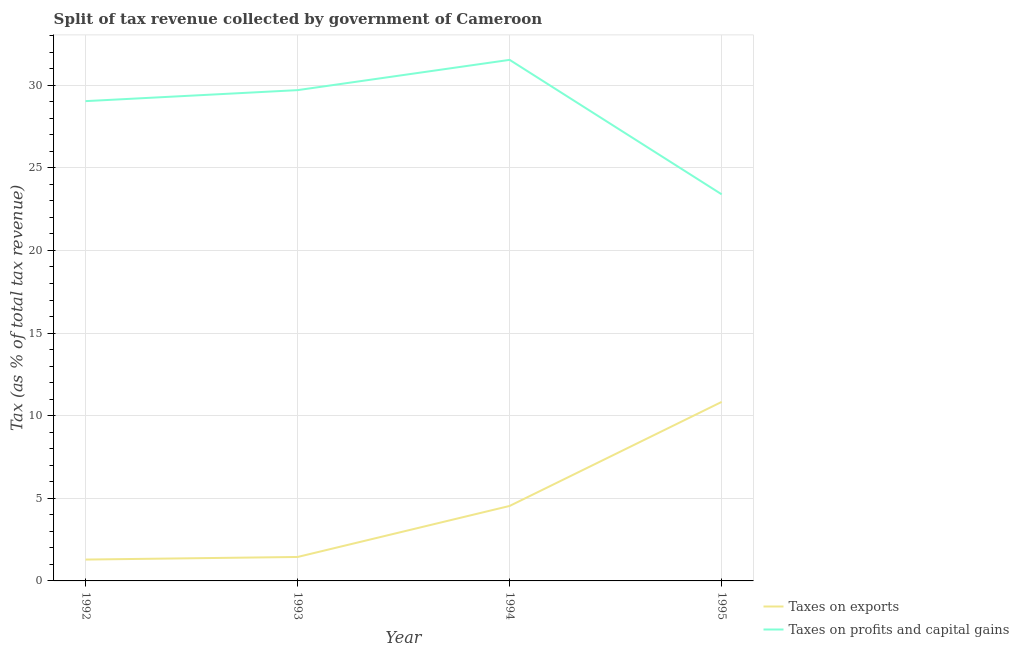Does the line corresponding to percentage of revenue obtained from taxes on exports intersect with the line corresponding to percentage of revenue obtained from taxes on profits and capital gains?
Keep it short and to the point. No. Is the number of lines equal to the number of legend labels?
Your answer should be compact. Yes. What is the percentage of revenue obtained from taxes on exports in 1994?
Your response must be concise. 4.54. Across all years, what is the maximum percentage of revenue obtained from taxes on exports?
Keep it short and to the point. 10.83. Across all years, what is the minimum percentage of revenue obtained from taxes on profits and capital gains?
Provide a succinct answer. 23.4. In which year was the percentage of revenue obtained from taxes on exports maximum?
Give a very brief answer. 1995. What is the total percentage of revenue obtained from taxes on profits and capital gains in the graph?
Your answer should be compact. 113.67. What is the difference between the percentage of revenue obtained from taxes on exports in 1992 and that in 1995?
Your answer should be very brief. -9.54. What is the difference between the percentage of revenue obtained from taxes on exports in 1992 and the percentage of revenue obtained from taxes on profits and capital gains in 1995?
Keep it short and to the point. -22.1. What is the average percentage of revenue obtained from taxes on exports per year?
Provide a succinct answer. 4.53. In the year 1993, what is the difference between the percentage of revenue obtained from taxes on exports and percentage of revenue obtained from taxes on profits and capital gains?
Offer a very short reply. -28.25. In how many years, is the percentage of revenue obtained from taxes on exports greater than 17 %?
Provide a short and direct response. 0. What is the ratio of the percentage of revenue obtained from taxes on profits and capital gains in 1993 to that in 1995?
Your answer should be compact. 1.27. What is the difference between the highest and the second highest percentage of revenue obtained from taxes on profits and capital gains?
Make the answer very short. 1.83. What is the difference between the highest and the lowest percentage of revenue obtained from taxes on exports?
Your answer should be compact. 9.54. Is the sum of the percentage of revenue obtained from taxes on profits and capital gains in 1994 and 1995 greater than the maximum percentage of revenue obtained from taxes on exports across all years?
Your answer should be compact. Yes. Is the percentage of revenue obtained from taxes on exports strictly less than the percentage of revenue obtained from taxes on profits and capital gains over the years?
Your answer should be compact. Yes. How many lines are there?
Make the answer very short. 2. How many years are there in the graph?
Ensure brevity in your answer.  4. Are the values on the major ticks of Y-axis written in scientific E-notation?
Keep it short and to the point. No. Does the graph contain any zero values?
Your response must be concise. No. Where does the legend appear in the graph?
Ensure brevity in your answer.  Bottom right. How many legend labels are there?
Provide a short and direct response. 2. What is the title of the graph?
Offer a very short reply. Split of tax revenue collected by government of Cameroon. What is the label or title of the X-axis?
Give a very brief answer. Year. What is the label or title of the Y-axis?
Keep it short and to the point. Tax (as % of total tax revenue). What is the Tax (as % of total tax revenue) in Taxes on exports in 1992?
Offer a very short reply. 1.29. What is the Tax (as % of total tax revenue) of Taxes on profits and capital gains in 1992?
Ensure brevity in your answer.  29.04. What is the Tax (as % of total tax revenue) in Taxes on exports in 1993?
Keep it short and to the point. 1.45. What is the Tax (as % of total tax revenue) in Taxes on profits and capital gains in 1993?
Ensure brevity in your answer.  29.7. What is the Tax (as % of total tax revenue) of Taxes on exports in 1994?
Your answer should be very brief. 4.54. What is the Tax (as % of total tax revenue) in Taxes on profits and capital gains in 1994?
Make the answer very short. 31.54. What is the Tax (as % of total tax revenue) of Taxes on exports in 1995?
Offer a terse response. 10.83. What is the Tax (as % of total tax revenue) of Taxes on profits and capital gains in 1995?
Provide a short and direct response. 23.4. Across all years, what is the maximum Tax (as % of total tax revenue) in Taxes on exports?
Provide a succinct answer. 10.83. Across all years, what is the maximum Tax (as % of total tax revenue) in Taxes on profits and capital gains?
Provide a short and direct response. 31.54. Across all years, what is the minimum Tax (as % of total tax revenue) of Taxes on exports?
Your answer should be very brief. 1.29. Across all years, what is the minimum Tax (as % of total tax revenue) in Taxes on profits and capital gains?
Your response must be concise. 23.4. What is the total Tax (as % of total tax revenue) of Taxes on exports in the graph?
Make the answer very short. 18.12. What is the total Tax (as % of total tax revenue) in Taxes on profits and capital gains in the graph?
Offer a very short reply. 113.67. What is the difference between the Tax (as % of total tax revenue) of Taxes on exports in 1992 and that in 1993?
Ensure brevity in your answer.  -0.16. What is the difference between the Tax (as % of total tax revenue) in Taxes on profits and capital gains in 1992 and that in 1993?
Your answer should be compact. -0.67. What is the difference between the Tax (as % of total tax revenue) in Taxes on exports in 1992 and that in 1994?
Ensure brevity in your answer.  -3.24. What is the difference between the Tax (as % of total tax revenue) in Taxes on profits and capital gains in 1992 and that in 1994?
Keep it short and to the point. -2.5. What is the difference between the Tax (as % of total tax revenue) of Taxes on exports in 1992 and that in 1995?
Ensure brevity in your answer.  -9.54. What is the difference between the Tax (as % of total tax revenue) in Taxes on profits and capital gains in 1992 and that in 1995?
Your answer should be compact. 5.64. What is the difference between the Tax (as % of total tax revenue) of Taxes on exports in 1993 and that in 1994?
Your answer should be compact. -3.09. What is the difference between the Tax (as % of total tax revenue) in Taxes on profits and capital gains in 1993 and that in 1994?
Ensure brevity in your answer.  -1.83. What is the difference between the Tax (as % of total tax revenue) of Taxes on exports in 1993 and that in 1995?
Your response must be concise. -9.39. What is the difference between the Tax (as % of total tax revenue) of Taxes on profits and capital gains in 1993 and that in 1995?
Keep it short and to the point. 6.31. What is the difference between the Tax (as % of total tax revenue) of Taxes on exports in 1994 and that in 1995?
Your answer should be very brief. -6.3. What is the difference between the Tax (as % of total tax revenue) in Taxes on profits and capital gains in 1994 and that in 1995?
Your answer should be very brief. 8.14. What is the difference between the Tax (as % of total tax revenue) in Taxes on exports in 1992 and the Tax (as % of total tax revenue) in Taxes on profits and capital gains in 1993?
Your answer should be compact. -28.41. What is the difference between the Tax (as % of total tax revenue) of Taxes on exports in 1992 and the Tax (as % of total tax revenue) of Taxes on profits and capital gains in 1994?
Ensure brevity in your answer.  -30.24. What is the difference between the Tax (as % of total tax revenue) of Taxes on exports in 1992 and the Tax (as % of total tax revenue) of Taxes on profits and capital gains in 1995?
Ensure brevity in your answer.  -22.1. What is the difference between the Tax (as % of total tax revenue) in Taxes on exports in 1993 and the Tax (as % of total tax revenue) in Taxes on profits and capital gains in 1994?
Keep it short and to the point. -30.09. What is the difference between the Tax (as % of total tax revenue) in Taxes on exports in 1993 and the Tax (as % of total tax revenue) in Taxes on profits and capital gains in 1995?
Your answer should be very brief. -21.95. What is the difference between the Tax (as % of total tax revenue) in Taxes on exports in 1994 and the Tax (as % of total tax revenue) in Taxes on profits and capital gains in 1995?
Make the answer very short. -18.86. What is the average Tax (as % of total tax revenue) in Taxes on exports per year?
Make the answer very short. 4.53. What is the average Tax (as % of total tax revenue) of Taxes on profits and capital gains per year?
Offer a terse response. 28.42. In the year 1992, what is the difference between the Tax (as % of total tax revenue) of Taxes on exports and Tax (as % of total tax revenue) of Taxes on profits and capital gains?
Your answer should be compact. -27.75. In the year 1993, what is the difference between the Tax (as % of total tax revenue) of Taxes on exports and Tax (as % of total tax revenue) of Taxes on profits and capital gains?
Make the answer very short. -28.25. In the year 1994, what is the difference between the Tax (as % of total tax revenue) in Taxes on exports and Tax (as % of total tax revenue) in Taxes on profits and capital gains?
Provide a succinct answer. -27. In the year 1995, what is the difference between the Tax (as % of total tax revenue) in Taxes on exports and Tax (as % of total tax revenue) in Taxes on profits and capital gains?
Your answer should be compact. -12.56. What is the ratio of the Tax (as % of total tax revenue) of Taxes on exports in 1992 to that in 1993?
Your answer should be very brief. 0.89. What is the ratio of the Tax (as % of total tax revenue) in Taxes on profits and capital gains in 1992 to that in 1993?
Offer a very short reply. 0.98. What is the ratio of the Tax (as % of total tax revenue) of Taxes on exports in 1992 to that in 1994?
Give a very brief answer. 0.28. What is the ratio of the Tax (as % of total tax revenue) in Taxes on profits and capital gains in 1992 to that in 1994?
Keep it short and to the point. 0.92. What is the ratio of the Tax (as % of total tax revenue) in Taxes on exports in 1992 to that in 1995?
Give a very brief answer. 0.12. What is the ratio of the Tax (as % of total tax revenue) in Taxes on profits and capital gains in 1992 to that in 1995?
Your answer should be very brief. 1.24. What is the ratio of the Tax (as % of total tax revenue) in Taxes on exports in 1993 to that in 1994?
Provide a succinct answer. 0.32. What is the ratio of the Tax (as % of total tax revenue) of Taxes on profits and capital gains in 1993 to that in 1994?
Your answer should be compact. 0.94. What is the ratio of the Tax (as % of total tax revenue) of Taxes on exports in 1993 to that in 1995?
Offer a very short reply. 0.13. What is the ratio of the Tax (as % of total tax revenue) in Taxes on profits and capital gains in 1993 to that in 1995?
Keep it short and to the point. 1.27. What is the ratio of the Tax (as % of total tax revenue) of Taxes on exports in 1994 to that in 1995?
Your answer should be very brief. 0.42. What is the ratio of the Tax (as % of total tax revenue) in Taxes on profits and capital gains in 1994 to that in 1995?
Your answer should be very brief. 1.35. What is the difference between the highest and the second highest Tax (as % of total tax revenue) of Taxes on exports?
Your response must be concise. 6.3. What is the difference between the highest and the second highest Tax (as % of total tax revenue) in Taxes on profits and capital gains?
Ensure brevity in your answer.  1.83. What is the difference between the highest and the lowest Tax (as % of total tax revenue) in Taxes on exports?
Keep it short and to the point. 9.54. What is the difference between the highest and the lowest Tax (as % of total tax revenue) of Taxes on profits and capital gains?
Your answer should be compact. 8.14. 